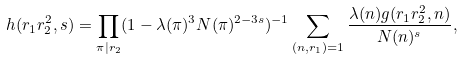Convert formula to latex. <formula><loc_0><loc_0><loc_500><loc_500>h ( r _ { 1 } r _ { 2 } ^ { 2 } , s ) = \prod _ { \pi | r _ { 2 } } ( 1 - \lambda ( \pi ) ^ { 3 } N ( \pi ) ^ { 2 - 3 s } ) ^ { - 1 } \sum _ { ( n , r _ { 1 } ) = 1 } \frac { \lambda ( n ) g ( r _ { 1 } r _ { 2 } ^ { 2 } , n ) } { N ( n ) ^ { s } } ,</formula> 